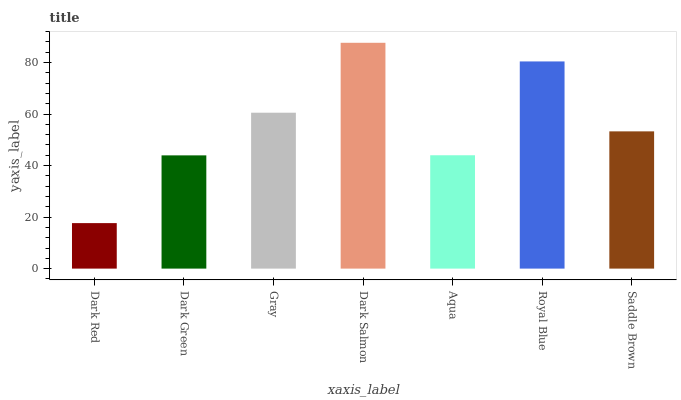Is Dark Red the minimum?
Answer yes or no. Yes. Is Dark Salmon the maximum?
Answer yes or no. Yes. Is Dark Green the minimum?
Answer yes or no. No. Is Dark Green the maximum?
Answer yes or no. No. Is Dark Green greater than Dark Red?
Answer yes or no. Yes. Is Dark Red less than Dark Green?
Answer yes or no. Yes. Is Dark Red greater than Dark Green?
Answer yes or no. No. Is Dark Green less than Dark Red?
Answer yes or no. No. Is Saddle Brown the high median?
Answer yes or no. Yes. Is Saddle Brown the low median?
Answer yes or no. Yes. Is Aqua the high median?
Answer yes or no. No. Is Dark Salmon the low median?
Answer yes or no. No. 